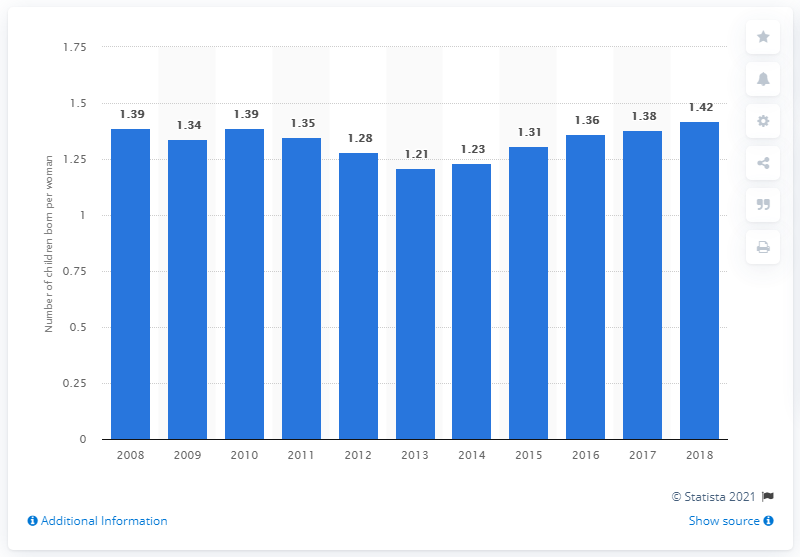What was the fertility rate in Portugal in 2018? In 2018, the fertility rate in Portugal was 1.42 children per woman, which indicates a slight increase from the previous year and part of a gradual rise since a low in 2013. 